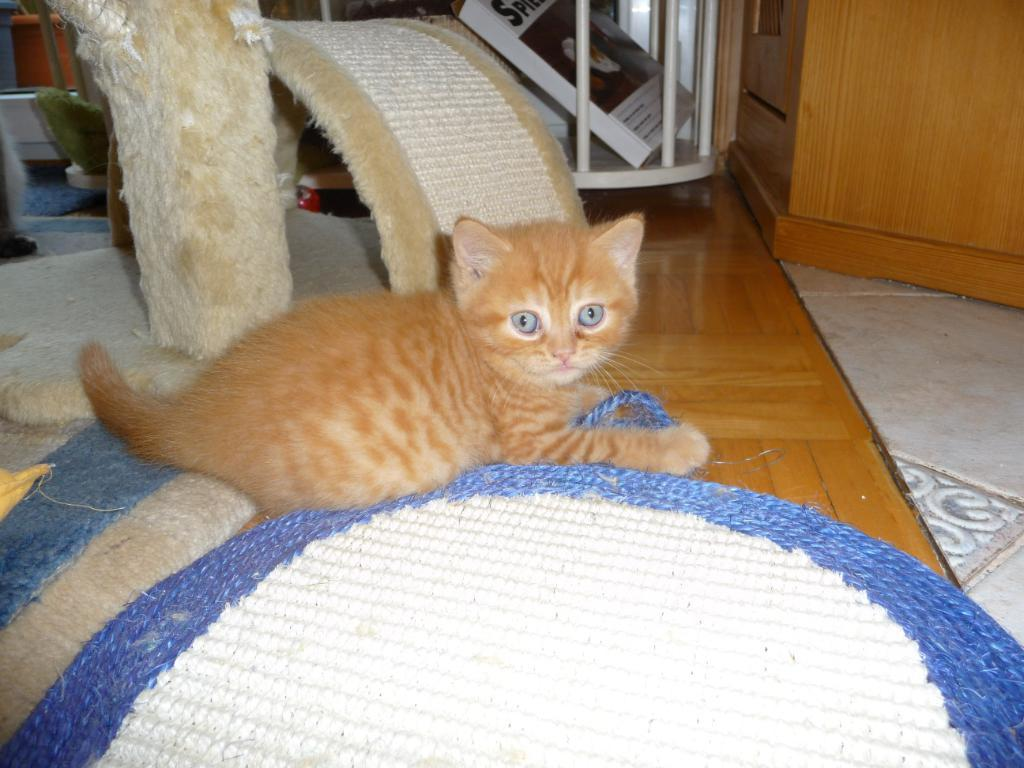What animal can be seen on a wooden platform in the image? There is a cat on a wooden platform in the image. What items are present in the image besides the cat and wooden platform? There are books and rods visible in the image. Can you describe the objects visible in the background of the image? Unfortunately, the provided facts do not give enough information to describe the objects visible in the background of the image. What time of day is it in the image, and who is serving the cat its afternoon snack? The provided facts do not give any information about the time of day or the presence of a servant in the image. 